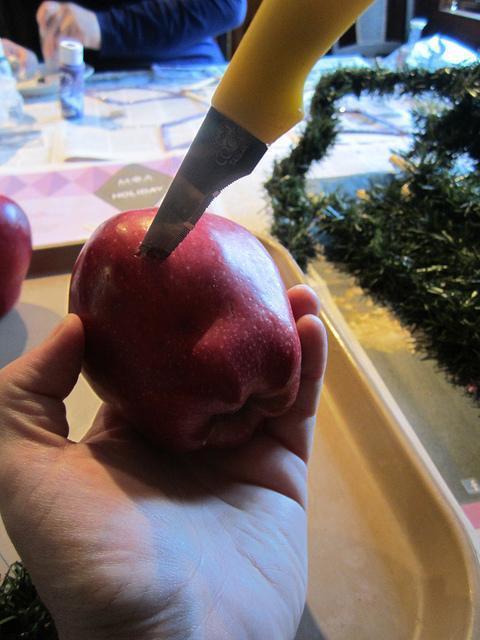How many people are there?
Give a very brief answer. 2. 